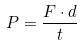<formula> <loc_0><loc_0><loc_500><loc_500>P = \frac { F \cdot d } { t }</formula> 